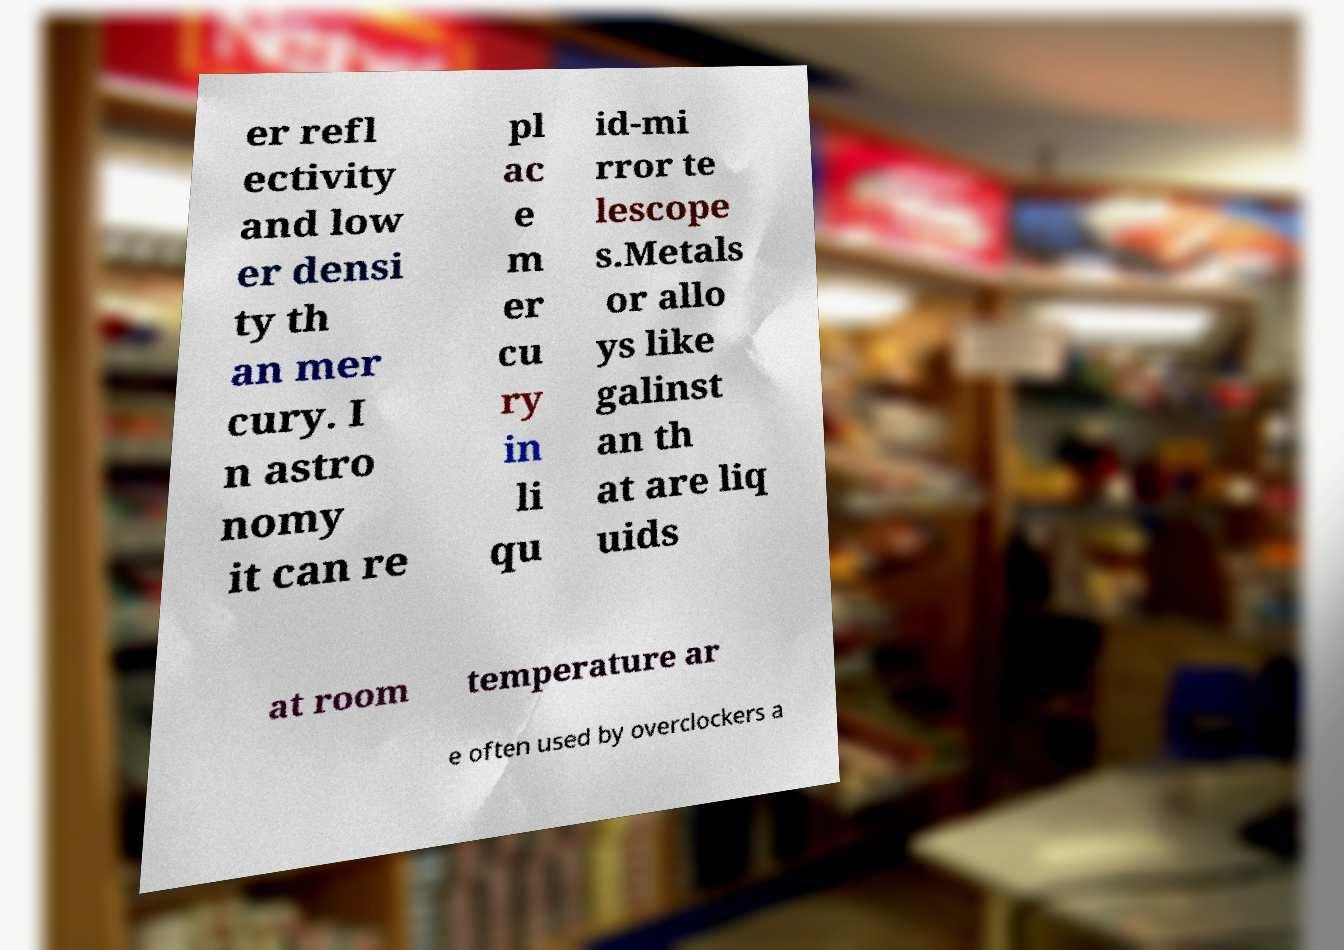Could you extract and type out the text from this image? er refl ectivity and low er densi ty th an mer cury. I n astro nomy it can re pl ac e m er cu ry in li qu id-mi rror te lescope s.Metals or allo ys like galinst an th at are liq uids at room temperature ar e often used by overclockers a 